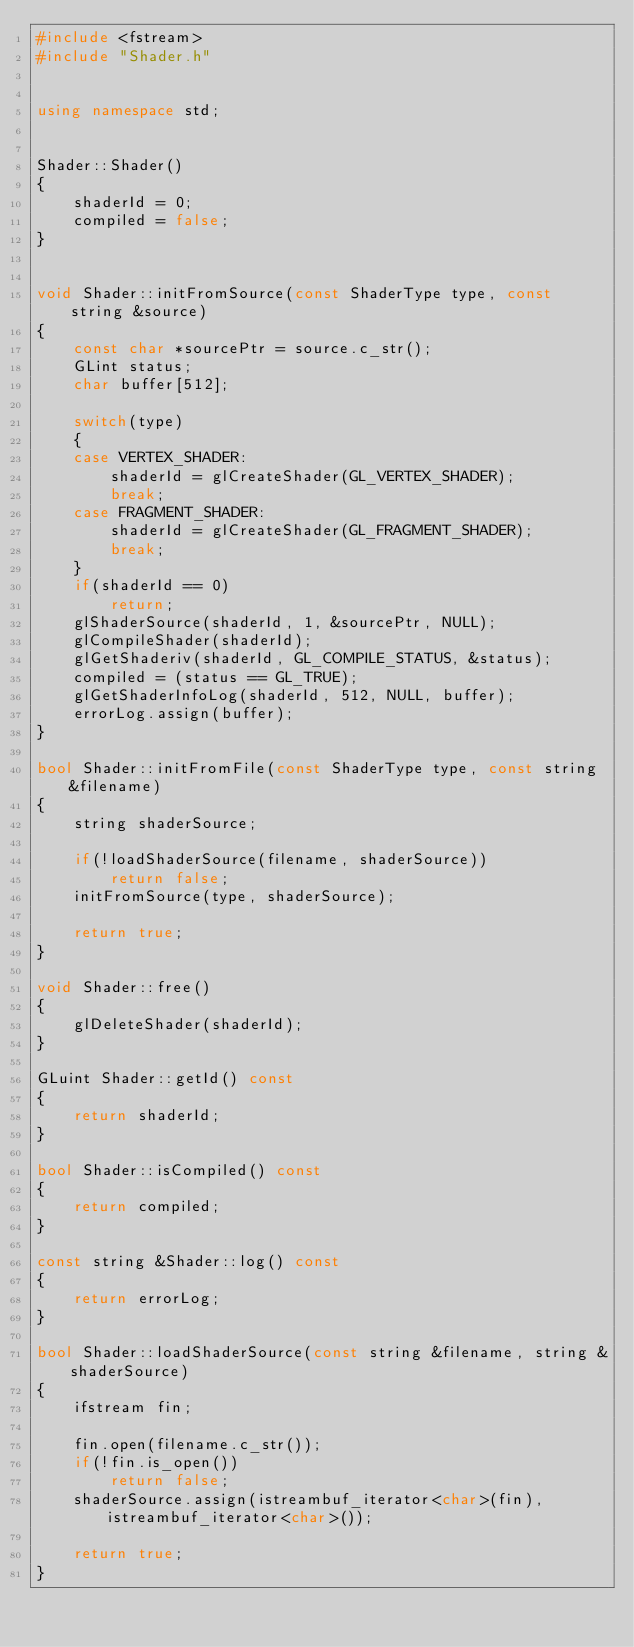<code> <loc_0><loc_0><loc_500><loc_500><_C++_>#include <fstream>
#include "Shader.h"


using namespace std;


Shader::Shader()
{
	shaderId = 0;
	compiled = false;
}


void Shader::initFromSource(const ShaderType type, const string &source)
{
	const char *sourcePtr = source.c_str();
	GLint status;
	char buffer[512];

	switch(type)
	{
	case VERTEX_SHADER:
		shaderId = glCreateShader(GL_VERTEX_SHADER);
		break;
	case FRAGMENT_SHADER:
		shaderId = glCreateShader(GL_FRAGMENT_SHADER);
		break;
	}
	if(shaderId == 0)
		return;
	glShaderSource(shaderId, 1, &sourcePtr, NULL);
	glCompileShader(shaderId);
	glGetShaderiv(shaderId, GL_COMPILE_STATUS, &status);
	compiled = (status == GL_TRUE);
	glGetShaderInfoLog(shaderId, 512, NULL, buffer);
	errorLog.assign(buffer);
}

bool Shader::initFromFile(const ShaderType type, const string &filename)
{
	string shaderSource;

	if(!loadShaderSource(filename, shaderSource))
		return false;
	initFromSource(type, shaderSource);

	return true;
}

void Shader::free()
{
	glDeleteShader(shaderId);
}

GLuint Shader::getId() const
{
	return shaderId;
}

bool Shader::isCompiled() const
{
	return compiled;
}

const string &Shader::log() const
{
	return errorLog;
}

bool Shader::loadShaderSource(const string &filename, string &shaderSource)
{
	ifstream fin;

	fin.open(filename.c_str());
	if(!fin.is_open())
		return false;
	shaderSource.assign(istreambuf_iterator<char>(fin), istreambuf_iterator<char>());

	return true;
}

</code> 